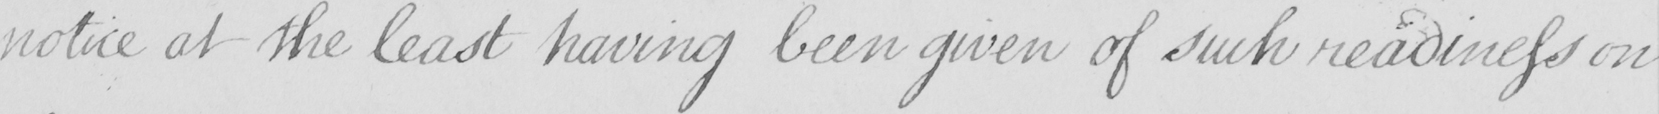What text is written in this handwritten line? notice at the least having been given of such readiness on 